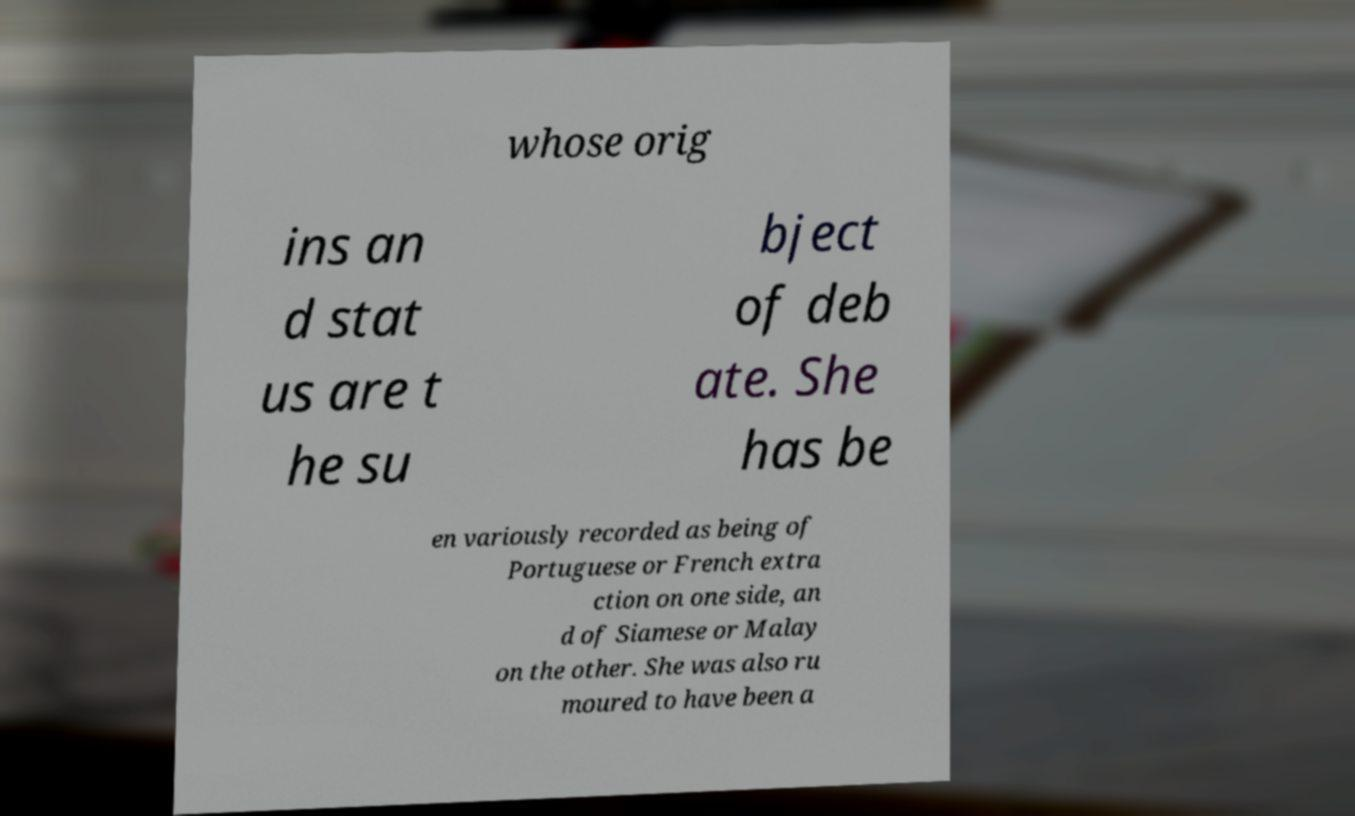Could you assist in decoding the text presented in this image and type it out clearly? whose orig ins an d stat us are t he su bject of deb ate. She has be en variously recorded as being of Portuguese or French extra ction on one side, an d of Siamese or Malay on the other. She was also ru moured to have been a 